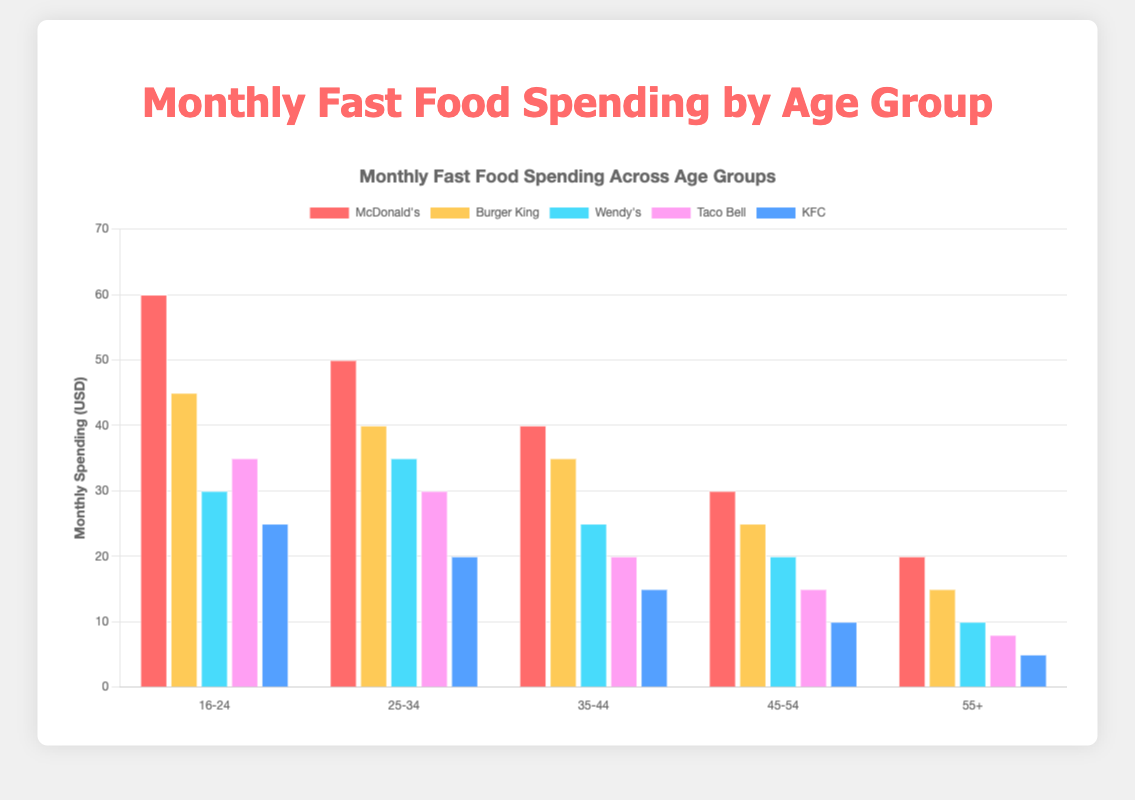Which age group spends the most on McDonald's? To determine this, compare the heights of the bars representing McDonald's spending across all age groups. The 16-24 age group bar is the highest.
Answer: 16-24 What is the total monthly spending on fast food for the 25-34 age group? Summing up all the spending for the 25-34 age group: McDonald's (50) + Burger King (40) + Wendy's (35) + Taco Bell (30) + KFC (20) = 50 + 40 + 35 + 30 + 20 = 175 USD.
Answer: 175 USD How does the spending on Burger King compare between the 16-24 and 55+ age groups? Compare the heights of the bars for Burger King in the 16-24 and 55+ age groups. The spending is higher in the 16-24 age group (45 USD) compared to the 55+ age group (15 USD).
Answer: 16-24 age group spends more Which brand has the least spending across all age groups, and what is the amount? Look for the brand with the shortest bars across all age groups. KFC has the least spending. The minimum is in the 55+ age group, where it is 5 USD.
Answer: KFC, 5 USD How much more is spent on Taco Bell than on KFC in the 35-44 age group? Subtract the KFC spending from the Taco Bell spending in the 35-44 age group: Taco Bell (20) - KFC (15) = 5 USD.
Answer: 5 USD What is the average monthly spending on Wendy's across all age groups? Sum up all the spending on Wendy's and divide by the number of age groups: (30 + 35 + 25 + 20 + 10) / 5 = 120 / 5 = 24 USD.
Answer: 24 USD Is the spending on McDonald's higher than the combined spending on Burger King and Taco Bell for the 45-54 age group? Compare McDonald's spending with the sum of Burger King and Taco Bell: McDonald's (30) vs. Burger King (25) + Taco Bell (15) = 40. McDonald's (30) is less than 40.
Answer: No What is the combined spending on fast food for the 45-54 and 55+ age groups for Burger King? Add the Burger King spending in both age groups: 25 + 15 = 40 USD.
Answer: 40 USD 